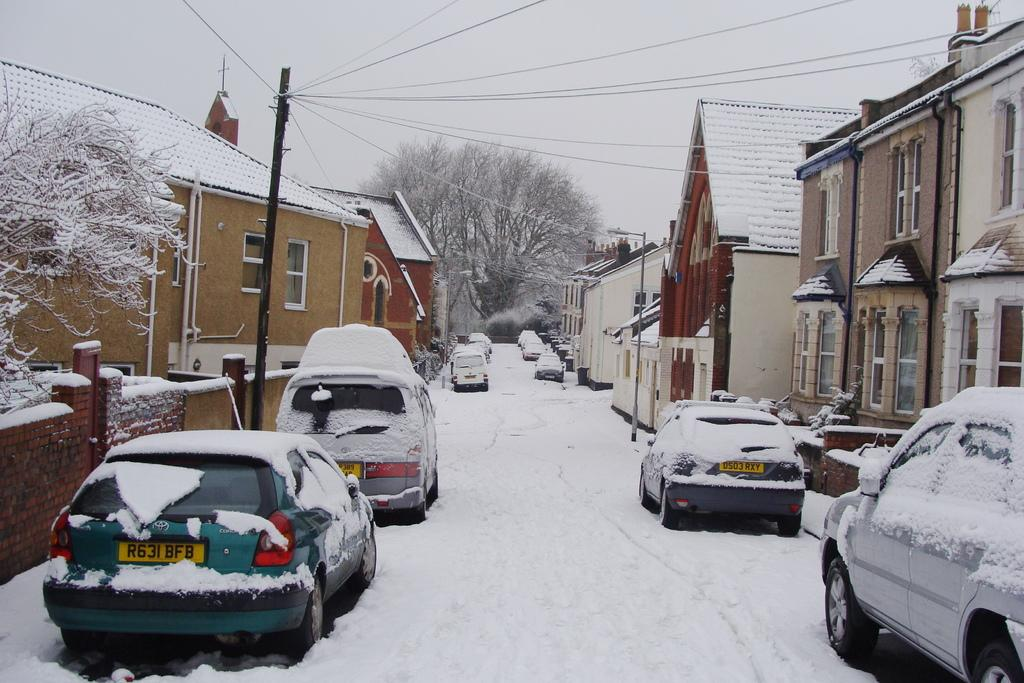What types of objects can be seen in the image? There are vehicles and buildings in the image. What is the condition of the trees in the image? The trees are covered with snow in the image. What can be seen in the background of the image? The sky is visible in the background of the image. Where is the stocking hanging in the image? There is no stocking present in the image. What type of sweater is the person wearing in the image? There is no person or sweater visible in the image. 